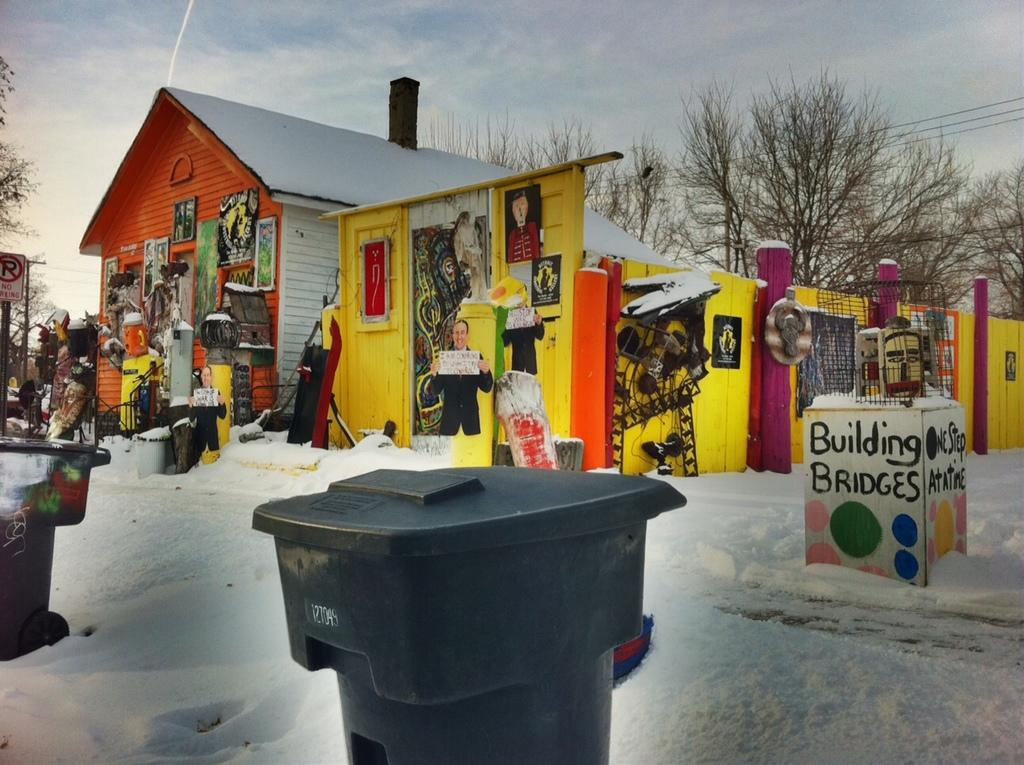<image>
Share a concise interpretation of the image provided. A garbage bin marked 1271049 sits in front of a colorful box marked Building Bridges. 